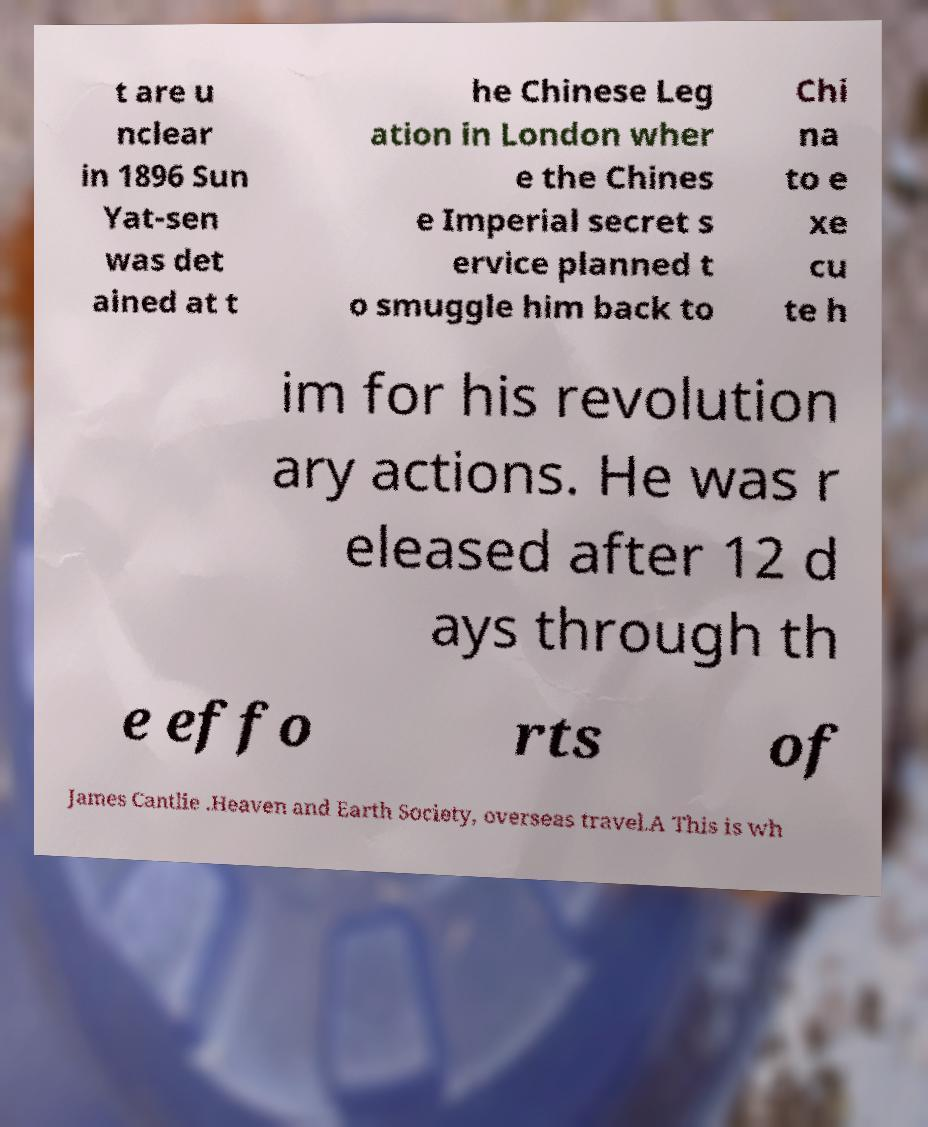Please identify and transcribe the text found in this image. t are u nclear in 1896 Sun Yat-sen was det ained at t he Chinese Leg ation in London wher e the Chines e Imperial secret s ervice planned t o smuggle him back to Chi na to e xe cu te h im for his revolution ary actions. He was r eleased after 12 d ays through th e effo rts of James Cantlie .Heaven and Earth Society, overseas travel.A This is wh 